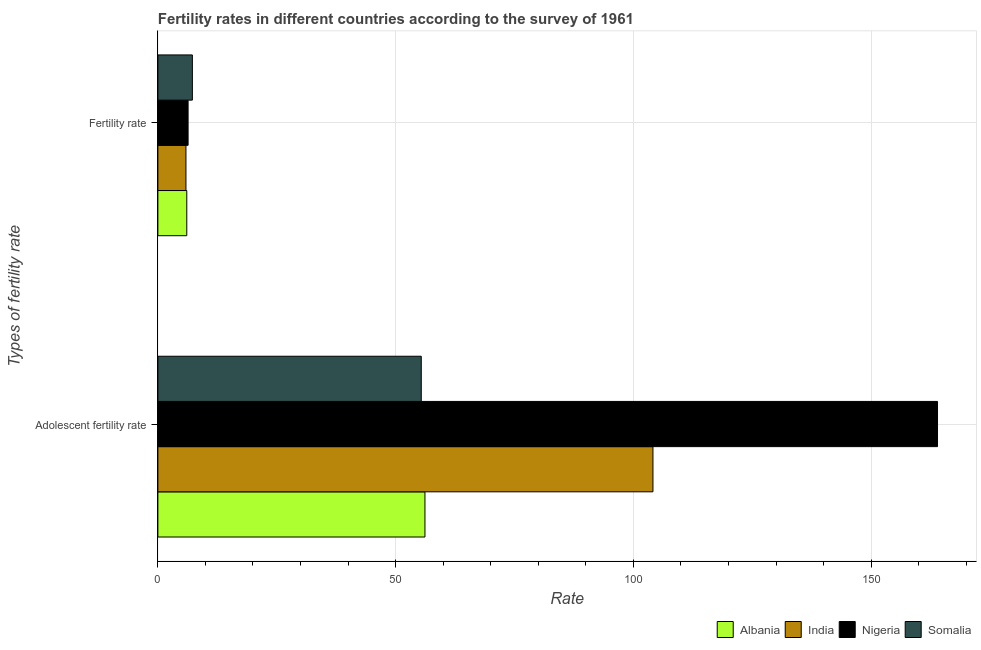Are the number of bars per tick equal to the number of legend labels?
Offer a terse response. Yes. How many bars are there on the 1st tick from the bottom?
Provide a succinct answer. 4. What is the label of the 2nd group of bars from the top?
Your answer should be compact. Adolescent fertility rate. What is the adolescent fertility rate in India?
Keep it short and to the point. 104.11. Across all countries, what is the maximum fertility rate?
Your response must be concise. 7.25. Across all countries, what is the minimum fertility rate?
Keep it short and to the point. 5.9. In which country was the adolescent fertility rate maximum?
Offer a very short reply. Nigeria. In which country was the adolescent fertility rate minimum?
Ensure brevity in your answer.  Somalia. What is the total adolescent fertility rate in the graph?
Offer a terse response. 379.62. What is the difference between the adolescent fertility rate in Nigeria and that in Somalia?
Provide a succinct answer. 108.57. What is the difference between the adolescent fertility rate in Albania and the fertility rate in Nigeria?
Make the answer very short. 49.81. What is the average fertility rate per country?
Your answer should be very brief. 6.4. What is the difference between the fertility rate and adolescent fertility rate in India?
Ensure brevity in your answer.  -98.21. In how many countries, is the adolescent fertility rate greater than 40 ?
Offer a very short reply. 4. What is the ratio of the fertility rate in Albania to that in India?
Your response must be concise. 1.03. What does the 2nd bar from the top in Adolescent fertility rate represents?
Offer a very short reply. Nigeria. What does the 2nd bar from the bottom in Adolescent fertility rate represents?
Make the answer very short. India. How many bars are there?
Keep it short and to the point. 8. Does the graph contain any zero values?
Your answer should be very brief. No. Does the graph contain grids?
Your response must be concise. Yes. What is the title of the graph?
Your response must be concise. Fertility rates in different countries according to the survey of 1961. What is the label or title of the X-axis?
Offer a very short reply. Rate. What is the label or title of the Y-axis?
Offer a terse response. Types of fertility rate. What is the Rate of Albania in Adolescent fertility rate?
Keep it short and to the point. 56.17. What is the Rate in India in Adolescent fertility rate?
Your response must be concise. 104.11. What is the Rate of Nigeria in Adolescent fertility rate?
Offer a terse response. 163.96. What is the Rate of Somalia in Adolescent fertility rate?
Ensure brevity in your answer.  55.39. What is the Rate in Albania in Fertility rate?
Ensure brevity in your answer.  6.08. What is the Rate of India in Fertility rate?
Your answer should be very brief. 5.9. What is the Rate in Nigeria in Fertility rate?
Ensure brevity in your answer.  6.35. What is the Rate of Somalia in Fertility rate?
Make the answer very short. 7.25. Across all Types of fertility rate, what is the maximum Rate in Albania?
Give a very brief answer. 56.17. Across all Types of fertility rate, what is the maximum Rate of India?
Your answer should be compact. 104.11. Across all Types of fertility rate, what is the maximum Rate in Nigeria?
Provide a succinct answer. 163.96. Across all Types of fertility rate, what is the maximum Rate of Somalia?
Your answer should be very brief. 55.39. Across all Types of fertility rate, what is the minimum Rate of Albania?
Ensure brevity in your answer.  6.08. Across all Types of fertility rate, what is the minimum Rate of India?
Provide a succinct answer. 5.9. Across all Types of fertility rate, what is the minimum Rate in Nigeria?
Provide a succinct answer. 6.35. Across all Types of fertility rate, what is the minimum Rate of Somalia?
Your answer should be compact. 7.25. What is the total Rate in Albania in the graph?
Your answer should be compact. 62.24. What is the total Rate in India in the graph?
Your answer should be very brief. 110.02. What is the total Rate in Nigeria in the graph?
Offer a terse response. 170.31. What is the total Rate in Somalia in the graph?
Your answer should be compact. 62.64. What is the difference between the Rate in Albania in Adolescent fertility rate and that in Fertility rate?
Your answer should be very brief. 50.09. What is the difference between the Rate of India in Adolescent fertility rate and that in Fertility rate?
Your answer should be very brief. 98.21. What is the difference between the Rate in Nigeria in Adolescent fertility rate and that in Fertility rate?
Make the answer very short. 157.6. What is the difference between the Rate of Somalia in Adolescent fertility rate and that in Fertility rate?
Your answer should be very brief. 48.14. What is the difference between the Rate of Albania in Adolescent fertility rate and the Rate of India in Fertility rate?
Offer a very short reply. 50.26. What is the difference between the Rate of Albania in Adolescent fertility rate and the Rate of Nigeria in Fertility rate?
Your answer should be very brief. 49.81. What is the difference between the Rate of Albania in Adolescent fertility rate and the Rate of Somalia in Fertility rate?
Ensure brevity in your answer.  48.91. What is the difference between the Rate in India in Adolescent fertility rate and the Rate in Nigeria in Fertility rate?
Provide a short and direct response. 97.76. What is the difference between the Rate in India in Adolescent fertility rate and the Rate in Somalia in Fertility rate?
Provide a succinct answer. 96.86. What is the difference between the Rate of Nigeria in Adolescent fertility rate and the Rate of Somalia in Fertility rate?
Provide a short and direct response. 156.7. What is the average Rate in Albania per Types of fertility rate?
Offer a very short reply. 31.12. What is the average Rate in India per Types of fertility rate?
Give a very brief answer. 55.01. What is the average Rate of Nigeria per Types of fertility rate?
Provide a short and direct response. 85.15. What is the average Rate in Somalia per Types of fertility rate?
Offer a very short reply. 31.32. What is the difference between the Rate of Albania and Rate of India in Adolescent fertility rate?
Give a very brief answer. -47.95. What is the difference between the Rate in Albania and Rate in Nigeria in Adolescent fertility rate?
Offer a terse response. -107.79. What is the difference between the Rate of Albania and Rate of Somalia in Adolescent fertility rate?
Provide a short and direct response. 0.78. What is the difference between the Rate of India and Rate of Nigeria in Adolescent fertility rate?
Offer a very short reply. -59.84. What is the difference between the Rate of India and Rate of Somalia in Adolescent fertility rate?
Ensure brevity in your answer.  48.72. What is the difference between the Rate in Nigeria and Rate in Somalia in Adolescent fertility rate?
Keep it short and to the point. 108.57. What is the difference between the Rate in Albania and Rate in India in Fertility rate?
Give a very brief answer. 0.17. What is the difference between the Rate of Albania and Rate of Nigeria in Fertility rate?
Your answer should be compact. -0.28. What is the difference between the Rate of Albania and Rate of Somalia in Fertility rate?
Make the answer very short. -1.18. What is the difference between the Rate of India and Rate of Nigeria in Fertility rate?
Your answer should be compact. -0.45. What is the difference between the Rate of India and Rate of Somalia in Fertility rate?
Give a very brief answer. -1.35. What is the difference between the Rate in Nigeria and Rate in Somalia in Fertility rate?
Your answer should be compact. -0.9. What is the ratio of the Rate in Albania in Adolescent fertility rate to that in Fertility rate?
Offer a very short reply. 9.24. What is the ratio of the Rate in India in Adolescent fertility rate to that in Fertility rate?
Your response must be concise. 17.64. What is the ratio of the Rate of Nigeria in Adolescent fertility rate to that in Fertility rate?
Keep it short and to the point. 25.82. What is the ratio of the Rate in Somalia in Adolescent fertility rate to that in Fertility rate?
Ensure brevity in your answer.  7.64. What is the difference between the highest and the second highest Rate of Albania?
Offer a very short reply. 50.09. What is the difference between the highest and the second highest Rate of India?
Provide a short and direct response. 98.21. What is the difference between the highest and the second highest Rate of Nigeria?
Ensure brevity in your answer.  157.6. What is the difference between the highest and the second highest Rate of Somalia?
Offer a terse response. 48.14. What is the difference between the highest and the lowest Rate in Albania?
Your response must be concise. 50.09. What is the difference between the highest and the lowest Rate in India?
Ensure brevity in your answer.  98.21. What is the difference between the highest and the lowest Rate in Nigeria?
Make the answer very short. 157.6. What is the difference between the highest and the lowest Rate of Somalia?
Ensure brevity in your answer.  48.14. 